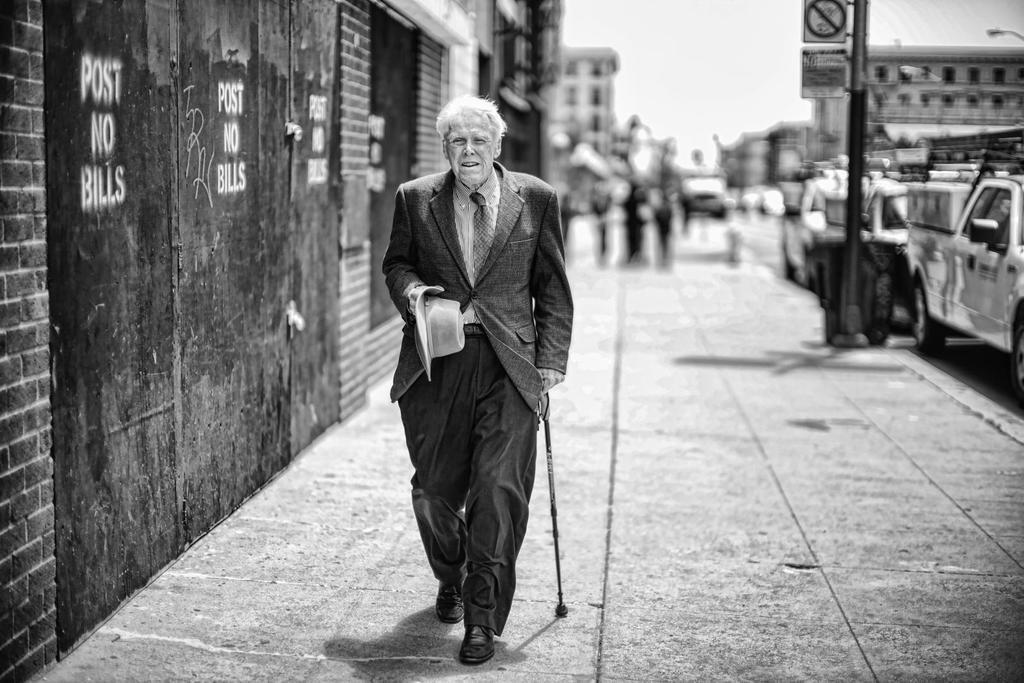Describe this image in one or two sentences. Black and white image. This man is holding a hat and stick. Here we can see a wall. Background it blur. We can see signboards, vehicles, people and buildings. 